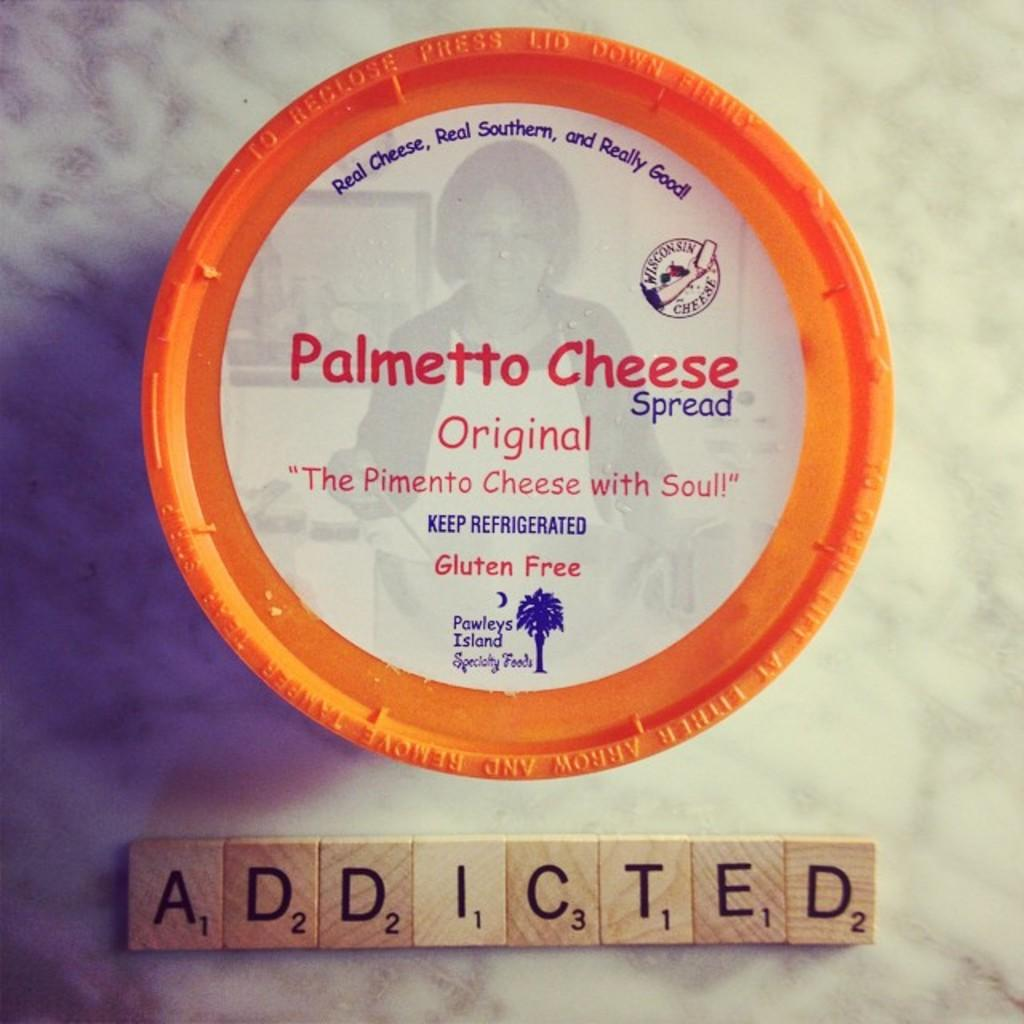What object is present in the image that might be used for serving food? There is a plate in the image that might be used for serving food. What can be seen on the plate? The plate has text printed on it. What objects are in the background of the image? There is a group of wood blocks in the background of the image. What can be seen on the wood blocks? The wood blocks have text on them. What type of mist can be seen surrounding the plate in the image? There is no mist present in the image; it is a clear image with a plate and wood blocks. What type of silver object is visible in the image? There is no silver object present in the image. 